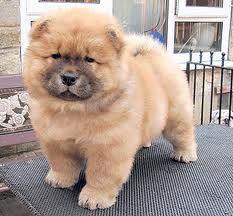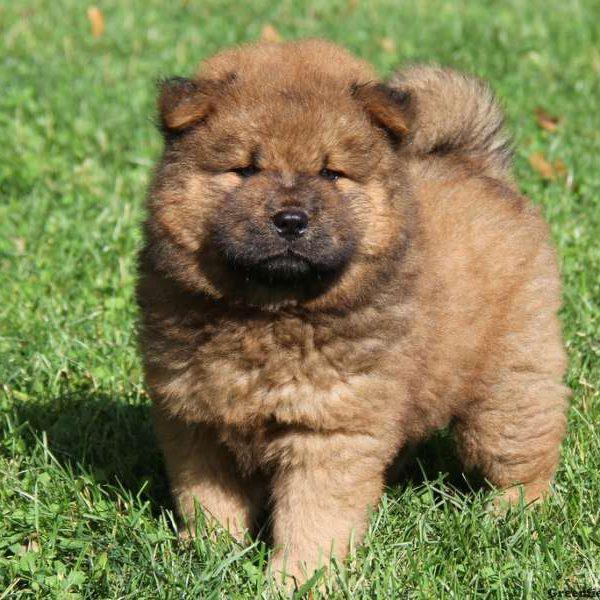The first image is the image on the left, the second image is the image on the right. For the images displayed, is the sentence "There are at least two dogs in the image on the left." factually correct? Answer yes or no. No. The first image is the image on the left, the second image is the image on the right. For the images displayed, is the sentence "There are no less than three dogs" factually correct? Answer yes or no. No. 